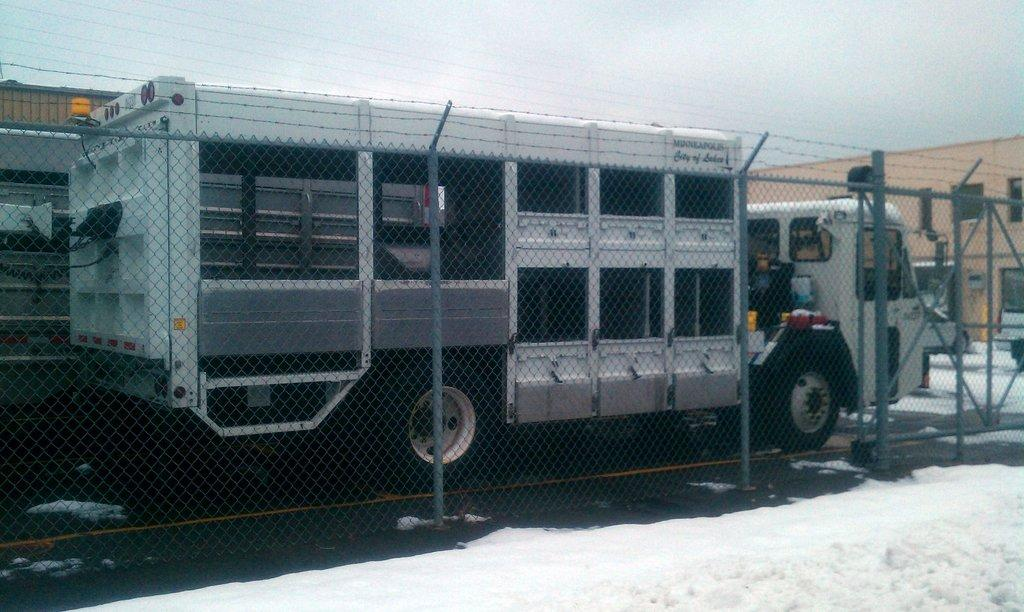What type of barrier can be seen in the image? There is a fence in the image. What else is present on the ground in the image? There are vehicles visible on the ground in the image. What type of structure can be seen in the image? There is a building visible in the image. What is visible in the background of the image? The sky is visible in the background of the image. How many bears are visible in the image? There are no bears present in the image. What type of account is being discussed in the image? There is no account being discussed in the image. 